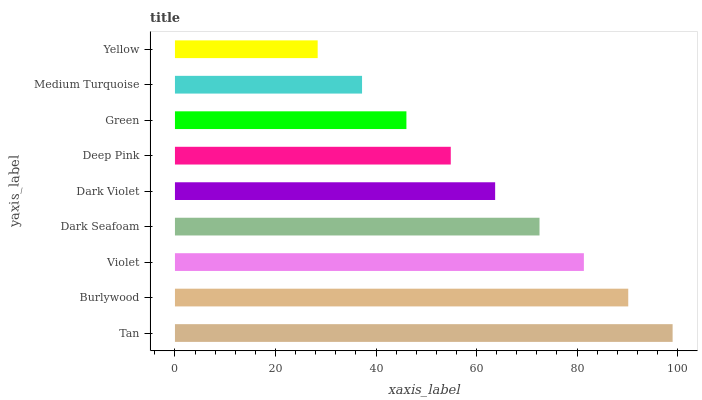Is Yellow the minimum?
Answer yes or no. Yes. Is Tan the maximum?
Answer yes or no. Yes. Is Burlywood the minimum?
Answer yes or no. No. Is Burlywood the maximum?
Answer yes or no. No. Is Tan greater than Burlywood?
Answer yes or no. Yes. Is Burlywood less than Tan?
Answer yes or no. Yes. Is Burlywood greater than Tan?
Answer yes or no. No. Is Tan less than Burlywood?
Answer yes or no. No. Is Dark Violet the high median?
Answer yes or no. Yes. Is Dark Violet the low median?
Answer yes or no. Yes. Is Dark Seafoam the high median?
Answer yes or no. No. Is Tan the low median?
Answer yes or no. No. 